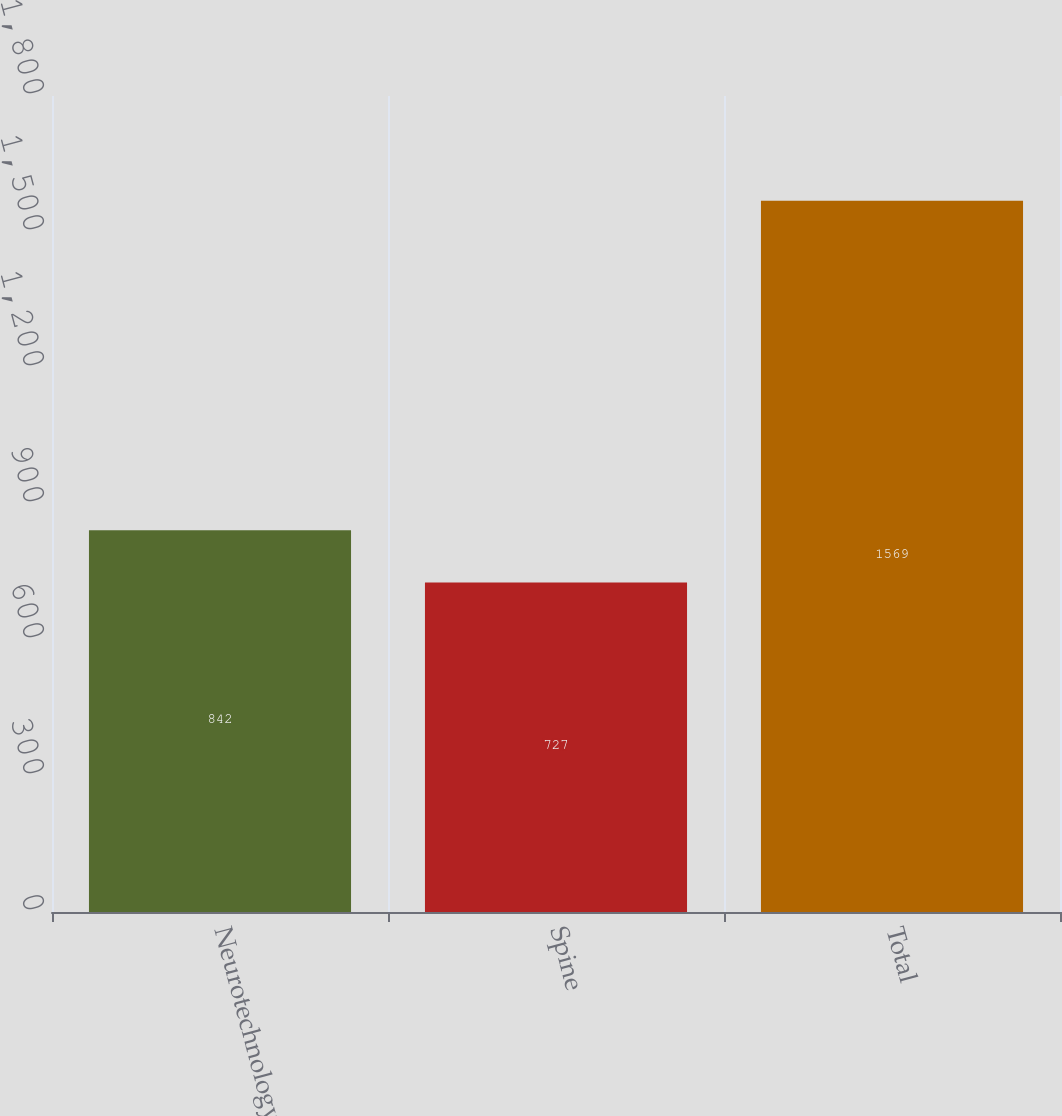Convert chart to OTSL. <chart><loc_0><loc_0><loc_500><loc_500><bar_chart><fcel>Neurotechnology<fcel>Spine<fcel>Total<nl><fcel>842<fcel>727<fcel>1569<nl></chart> 